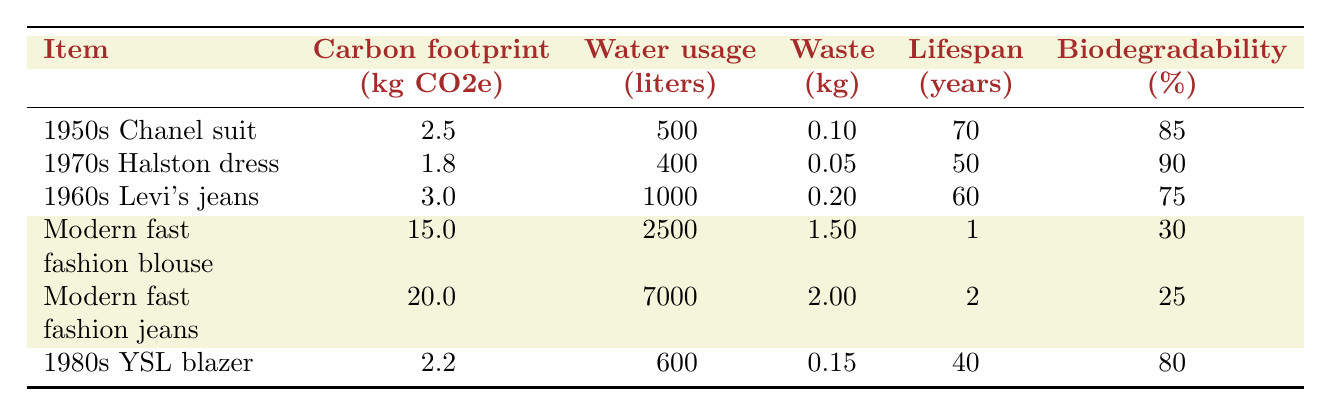What is the carbon footprint of the 1960s Levi's jeans? The table lists the carbon footprint of the 1960s Levi's jeans as 3.0 kg CO2e.
Answer: 3.0 kg CO2e Which item has the lowest water usage? The water usage values are 500 liters for the 1950s Chanel suit, 400 liters for the 1970s Halston dress, 1000 liters for the 1960s Levi's jeans, 2500 liters for the modern fast fashion blouse, 7000 liters for the modern fast fashion jeans, and 600 liters for the 1980s YSL blazer. The lowest value is 400 liters for the 1970s Halston dress.
Answer: 1970s Halston dress What is the total waste produced by the modern fast fashion blouse and jeans? The waste produced is 1.5 kg for the modern fast fashion blouse and 2.0 kg for the modern fast fashion jeans. Summing these values gives 1.5 + 2.0 = 3.5 kg.
Answer: 3.5 kg True or False: The 1980s Yves Saint Laurent blazer has a lifespan longer than the modern fast fashion blouse. The lifespan of the 1980s YSL blazer is 40 years, while the lifespan of the modern fast fashion blouse is only 1 year. Since 40 years is greater than 1 year, the statement is true.
Answer: True What is the average biodegradability percentage of vintage items (1950s Chanel suit, 1970s Halston dress, 1960s Levi's jeans, and 1980s YSL blazer)? The biodegradability percentages for the vintage items are 85%, 90%, 75%, and 80%. To find the average, sum these values: 85 + 90 + 75 + 80 = 330, then divide by 4 (the number of items): 330 / 4 = 82.5%.
Answer: 82.5% How does the carbon footprint of modern fast fashion jeans compare to the 1950s Chanel suit? The carbon footprint of modern fast fashion jeans is 20.0 kg CO2e and for the 1950s Chanel suit, it is 2.5 kg CO2e. The difference is 20.0 - 2.5 = 17.5 kg CO2e, indicating the modern fast fashion jeans have a significantly higher carbon footprint.
Answer: 17.5 kg CO2e Which item produced the most waste? The modern fast fashion blouse produced 1.5 kg of waste, while the modern fast fashion jeans produced 2.0 kg. The 1960s Levi's jeans produced 0.2 kg, the 1950s Chanel suit produced 0.1 kg, the 1970s Halston dress produced 0.05 kg, and the 1980s YSL blazer produced 0.15 kg. The highest waste produced is from the modern fast fashion jeans.
Answer: Modern fast fashion jeans What is the difference in lifespan between the longest-lasting vintage item and the shortest-lasting modern fast fashion item? The longest-lasting vintage item is the 1950s Chanel suit with 70 years, and the shortest-lasting modern fast fashion item is the modern fast fashion blouse with 1 year. The difference in lifespan is 70 - 1 = 69 years.
Answer: 69 years What is the total water usage for all vintage items combined? The water usage for the vintage items is 500 liters for the 1950s Chanel suit, 400 liters for the 1970s Halston dress, 1000 liters for the 1960s Levi's jeans, and 600 liters for the 1980s YSL blazer. Summing these gives 500 + 400 + 1000 + 600 = 2500 liters.
Answer: 2500 liters 